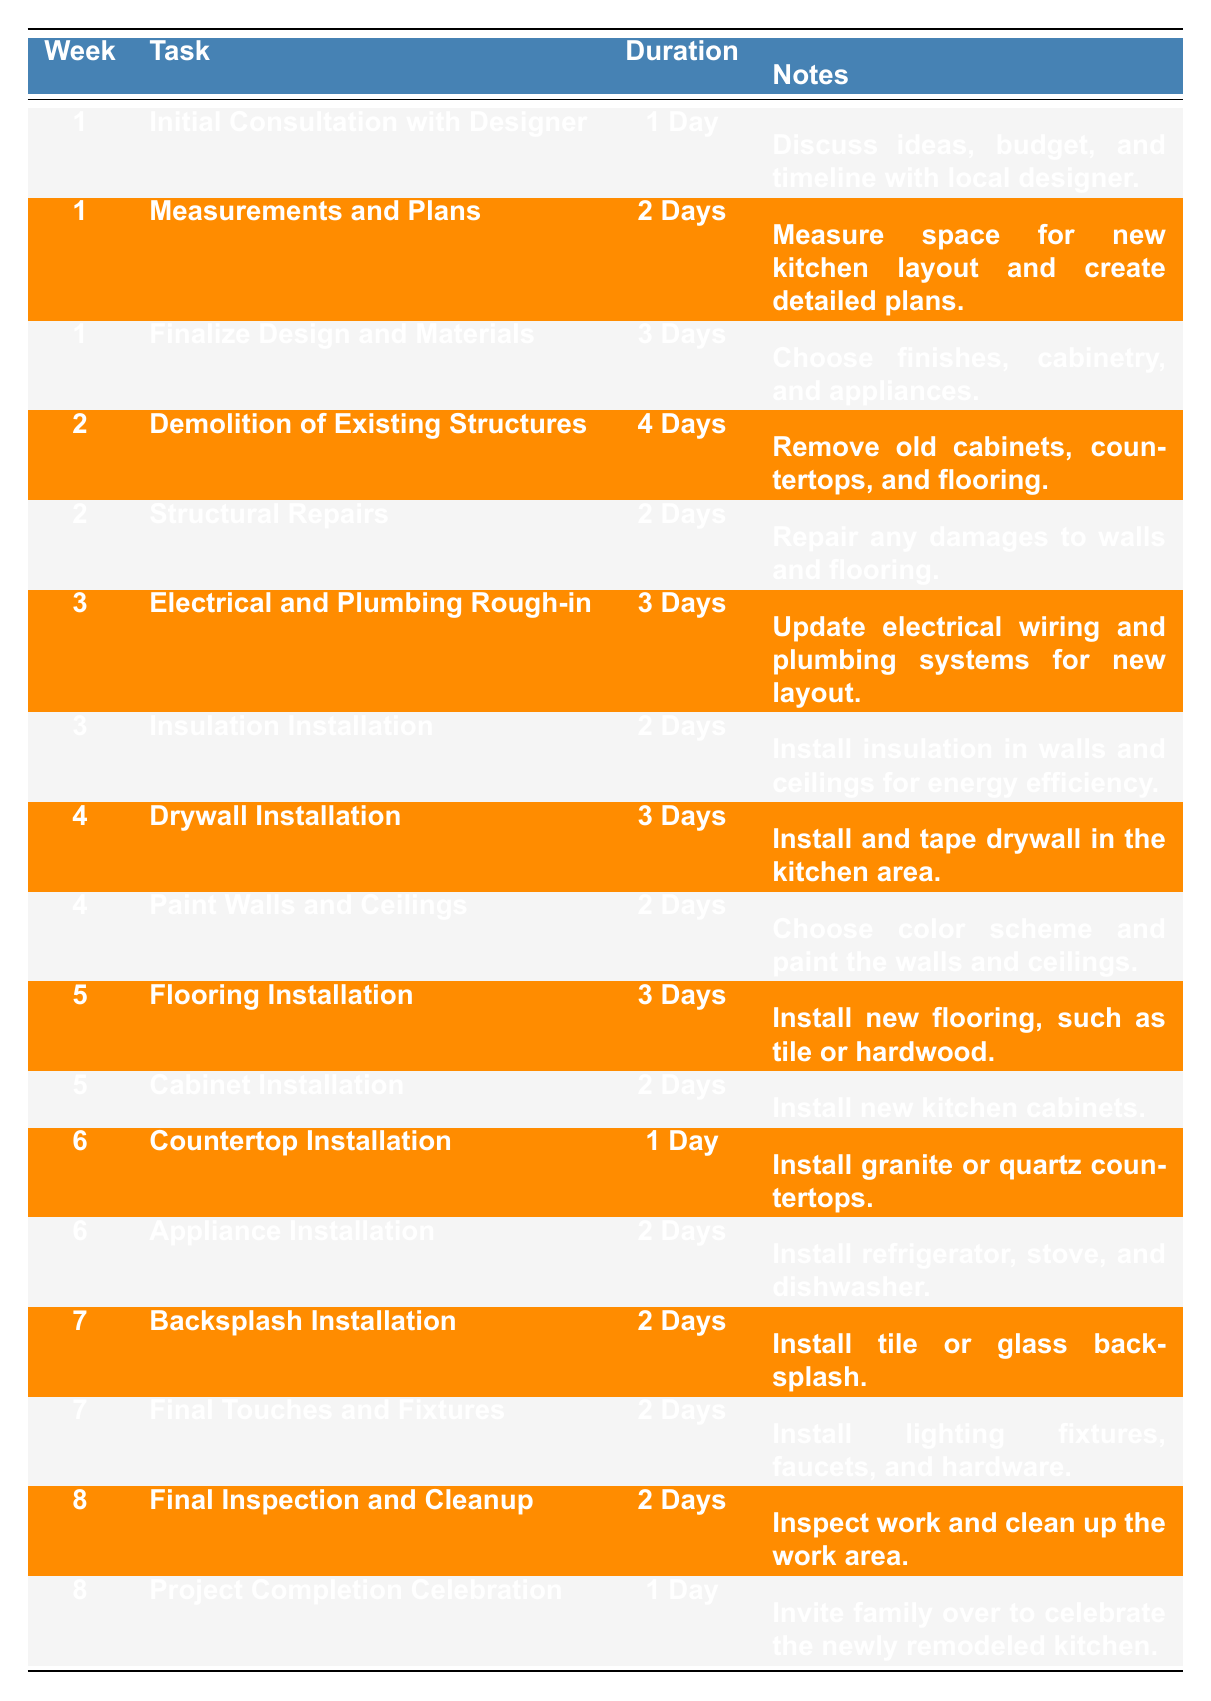What task is scheduled for Week 3? In Week 3, there are two tasks listed: "Electrical and Plumbing Rough-in" and "Insulation Installation".
Answer: Electrical and Plumbing Rough-in, Insulation Installation How long is the "Demolition of Existing Structures" task expected to take? The task "Demolition of Existing Structures" is scheduled for 4 days as noted in the Duration column.
Answer: 4 Days Which task takes the least amount of time to complete? The task "Countertop Installation" takes the least amount of time, with a duration of 1 day.
Answer: Countertop Installation How many total days are allocated for tasks in Week 1? In Week 1, there are three tasks with durations of 1 day, 2 days, and 3 days respectively. The total days are 1 + 2 + 3 = 6 days.
Answer: 6 Days Is there any task that requires exactly 2 days? Yes, there are several tasks that require exactly 2 days, including "Measurements and Plans" and "Structural Repairs".
Answer: Yes What is the total duration for tasks across all weeks? To find the total duration, sum all durations: 1 + 2 + 3 + 4 + 2 + 3 + 2 + 3 + 2 + 3 + 1 + 2 + 2 + 2 + 2 + 1 = 30 days total across all tasks.
Answer: 30 Days How many tasks are planned for week 8? Week 8 includes two tasks: "Final Inspection and Cleanup" and "Project Completion Celebration".
Answer: 2 Tasks What is the average duration of all tasks? The total duration of all tasks is 30 days and there are a total of 16 tasks, so to find the average, divide 30 by 16. 30/16 = 1.875 days as the average duration.
Answer: 1.875 Days Which task is scheduled to occur immediately after the "Cabinet Installation"? The task immediately following "Cabinet Installation" is "Countertop Installation".
Answer: Countertop Installation How many tasks involve installation and what are they? Four installation tasks are listed: "Countertop Installation", "Appliance Installation", "Flooring Installation", and "Backsplash Installation".
Answer: 4 Tasks: Countertop Installation, Appliance Installation, Flooring Installation, Backsplash Installation 